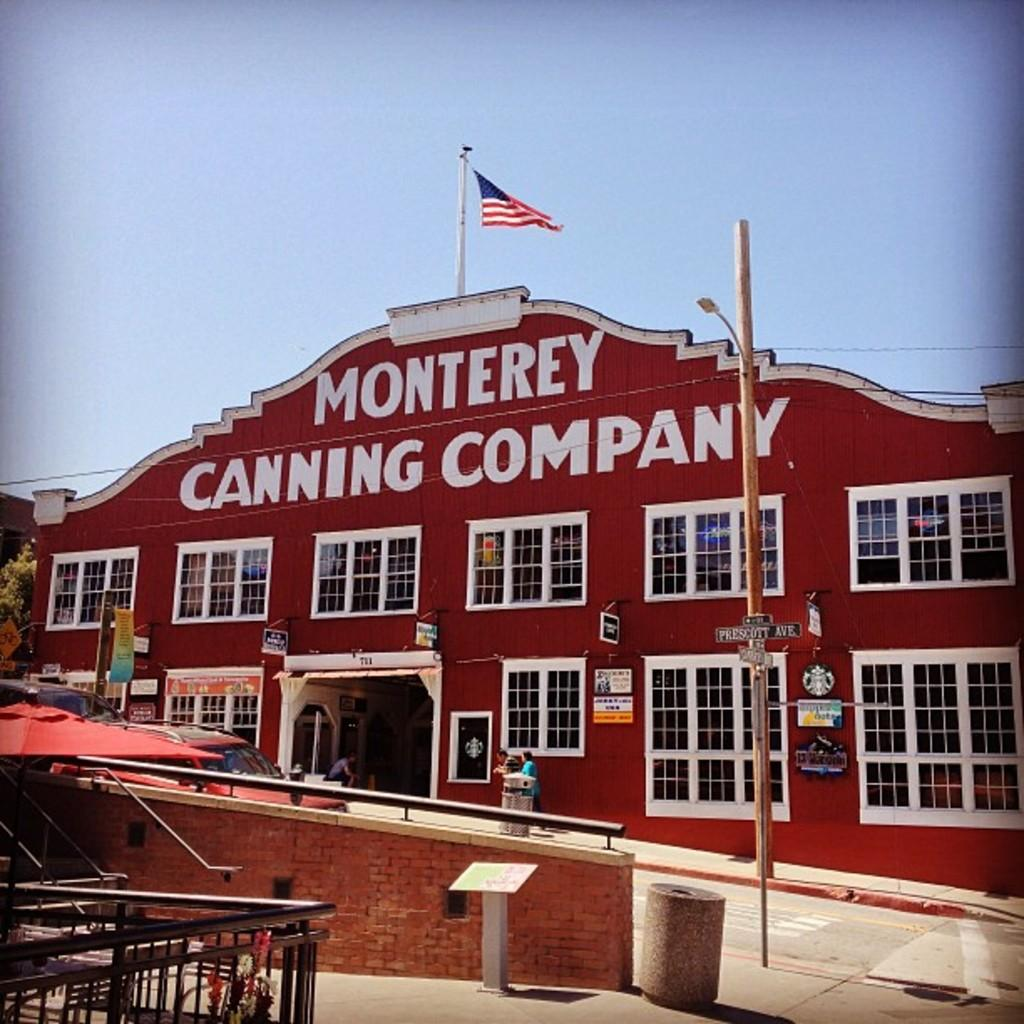What type of structure is visible in the image? There is a building in the image. What feature can be seen on the building? The building has windows. Is there any symbol or emblem on the building? Yes, there is a flag on the building. What can be found on the path in the image? There is a bin on the path in the image. What mode of transportation is present on the road in the image? There is a vehicle on the road in the image. What is the purpose of the flag in the image? The purpose of the flag in the image cannot be determined from the image alone, as it could serve various purposes such as representing a country, organization, or event. 